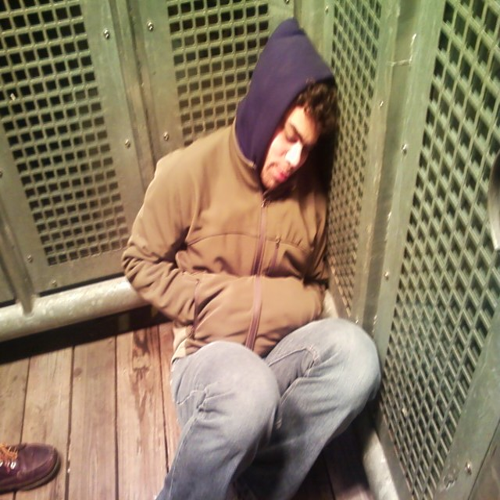Can you describe the person's attire? Certainly. The individual is wearing a hooded jacket and jeans, which are relatively casual and common attire. The outfit looks comfortable and suitable for cooler weather, given the attire's composition and the person's decision to wear the hood. 